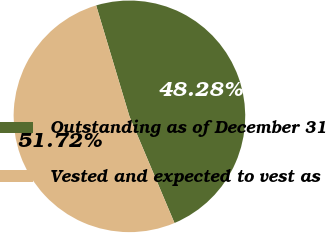Convert chart to OTSL. <chart><loc_0><loc_0><loc_500><loc_500><pie_chart><fcel>Outstanding as of December 31<fcel>Vested and expected to vest as<nl><fcel>48.28%<fcel>51.72%<nl></chart> 